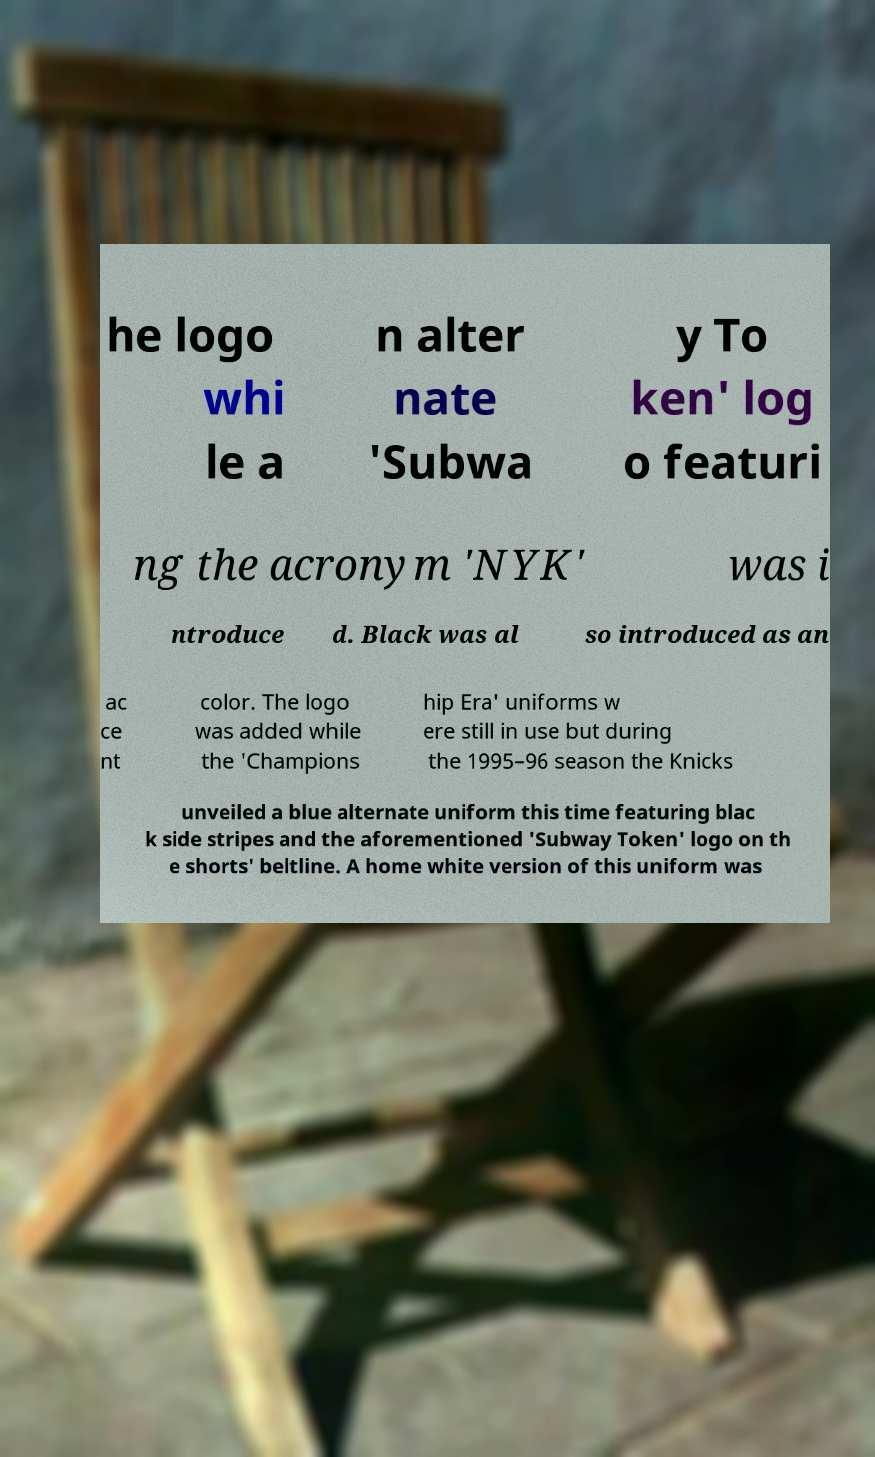There's text embedded in this image that I need extracted. Can you transcribe it verbatim? he logo whi le a n alter nate 'Subwa y To ken' log o featuri ng the acronym 'NYK' was i ntroduce d. Black was al so introduced as an ac ce nt color. The logo was added while the 'Champions hip Era' uniforms w ere still in use but during the 1995–96 season the Knicks unveiled a blue alternate uniform this time featuring blac k side stripes and the aforementioned 'Subway Token' logo on th e shorts' beltline. A home white version of this uniform was 